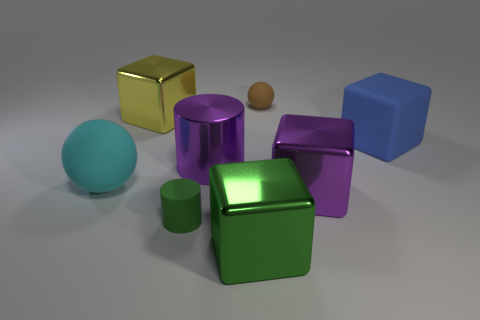What color is the small rubber object behind the purple metallic thing left of the object behind the large yellow shiny cube? The small rubber object located behind the purple metallic item, and to the left of the object situated behind the large yellow shiny cube, is brown. 